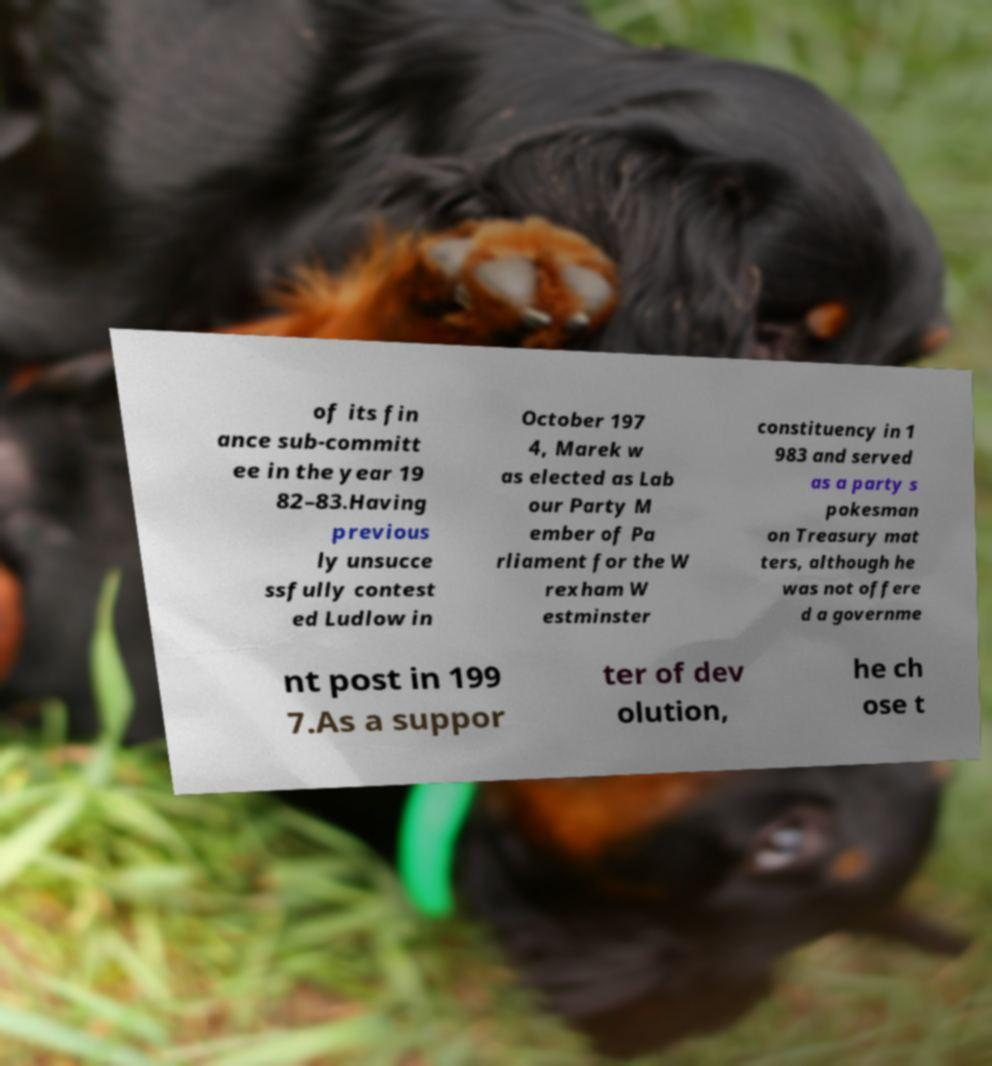There's text embedded in this image that I need extracted. Can you transcribe it verbatim? of its fin ance sub-committ ee in the year 19 82–83.Having previous ly unsucce ssfully contest ed Ludlow in October 197 4, Marek w as elected as Lab our Party M ember of Pa rliament for the W rexham W estminster constituency in 1 983 and served as a party s pokesman on Treasury mat ters, although he was not offere d a governme nt post in 199 7.As a suppor ter of dev olution, he ch ose t 